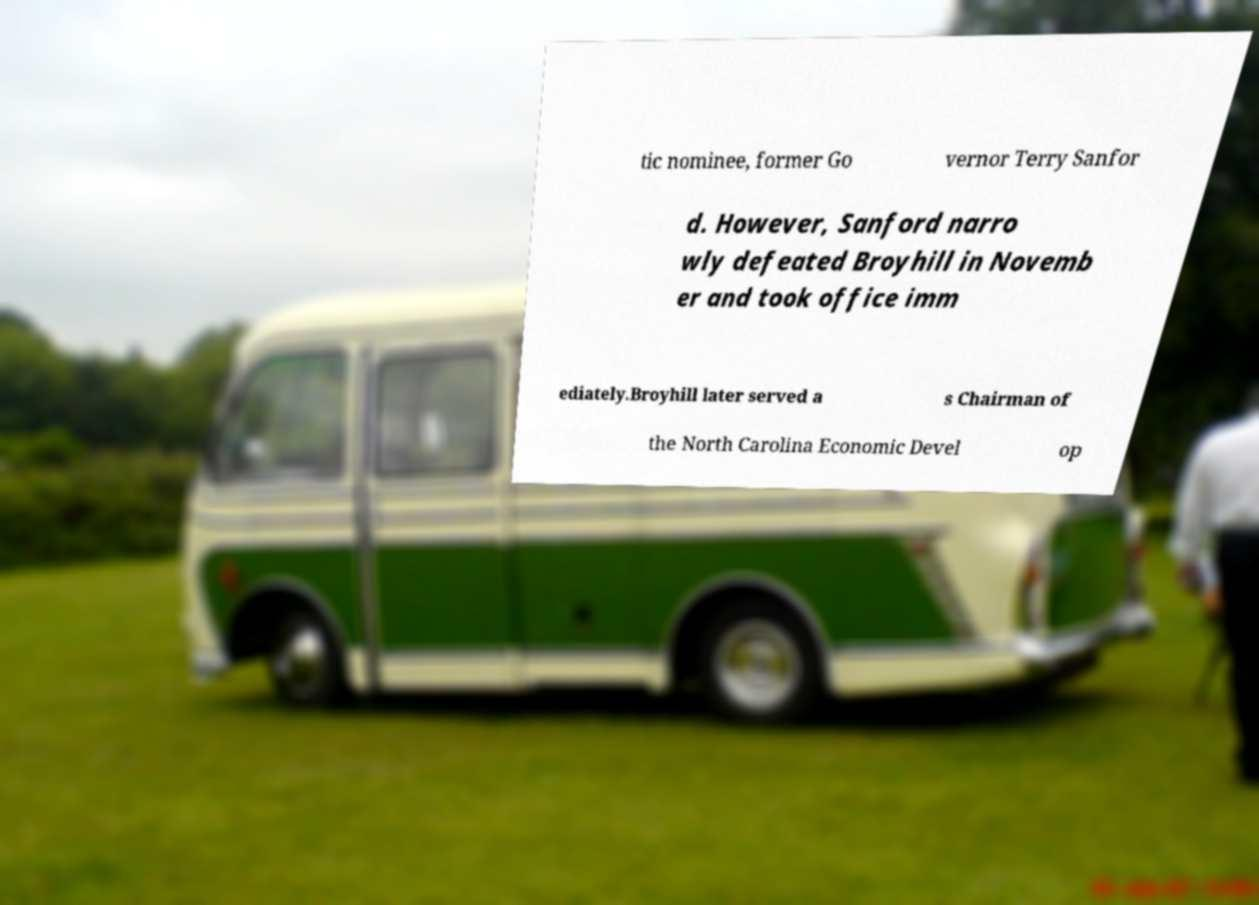Can you read and provide the text displayed in the image?This photo seems to have some interesting text. Can you extract and type it out for me? tic nominee, former Go vernor Terry Sanfor d. However, Sanford narro wly defeated Broyhill in Novemb er and took office imm ediately.Broyhill later served a s Chairman of the North Carolina Economic Devel op 